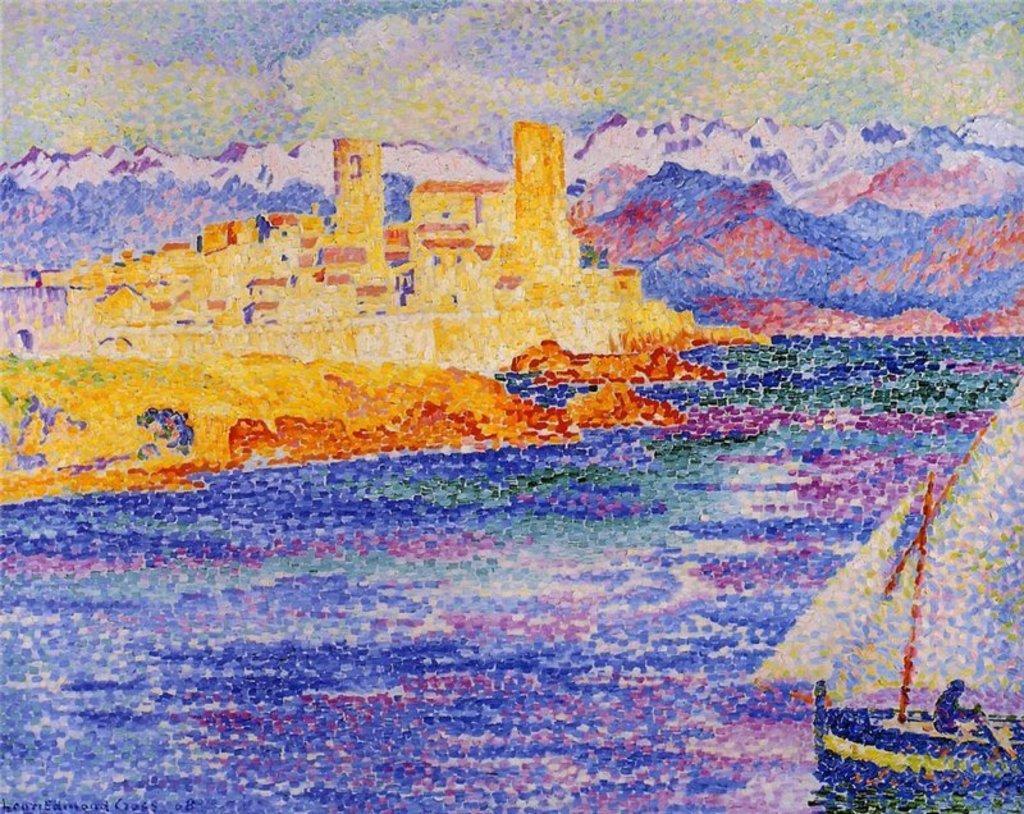Please provide a concise description of this image. In this image I can see the painting. I can see the water, a boat, a person sitting in the boat, few buildings, few mountains and the sky. 